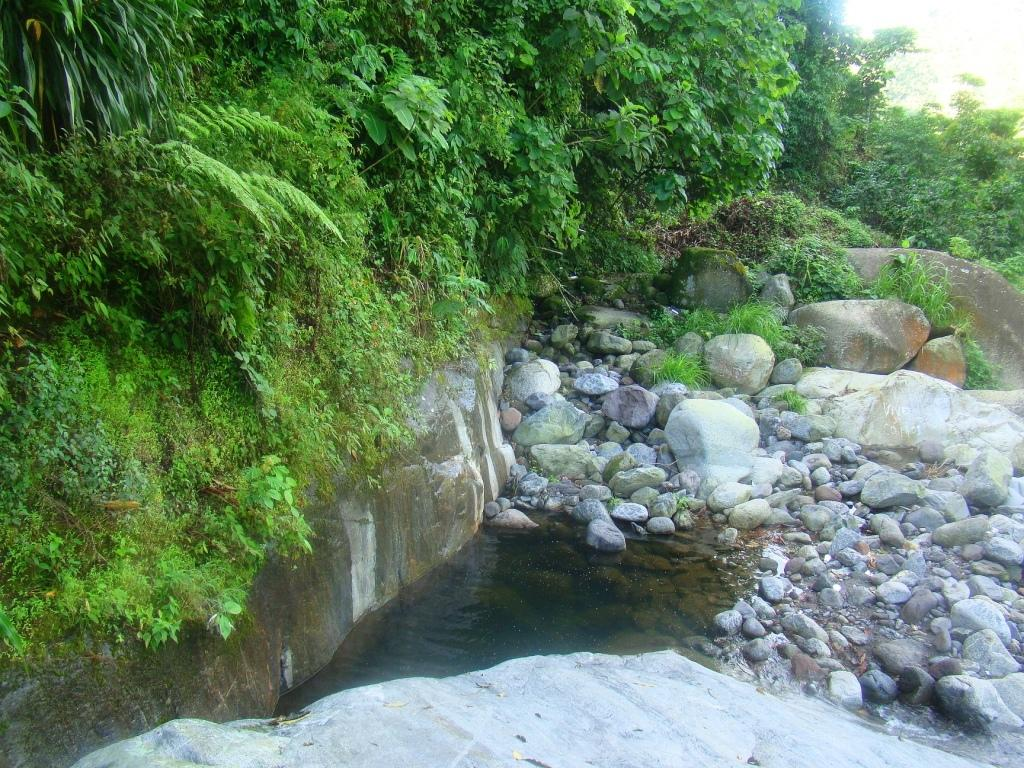What type of natural elements can be seen in the image? There are stones, water, and trees visible in the image. Can you describe the water in the image? The water is visible in the image. What type of vegetation is present in the image? There are trees in the image. How many fingers can be seen touching the stones in the image? There are no fingers visible in the image; it only shows stones, water, and trees. 